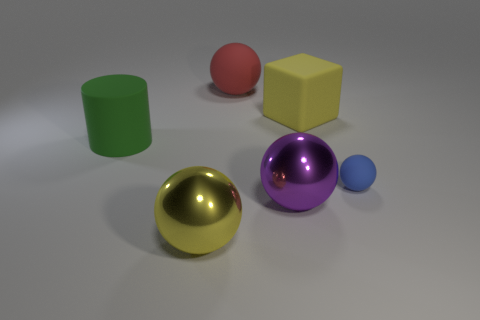Add 2 big red rubber balls. How many objects exist? 8 Subtract all cyan balls. Subtract all gray cylinders. How many balls are left? 4 Subtract all cylinders. How many objects are left? 5 Subtract all big green objects. Subtract all tiny matte balls. How many objects are left? 4 Add 2 green things. How many green things are left? 3 Add 5 large yellow things. How many large yellow things exist? 7 Subtract 1 green cylinders. How many objects are left? 5 